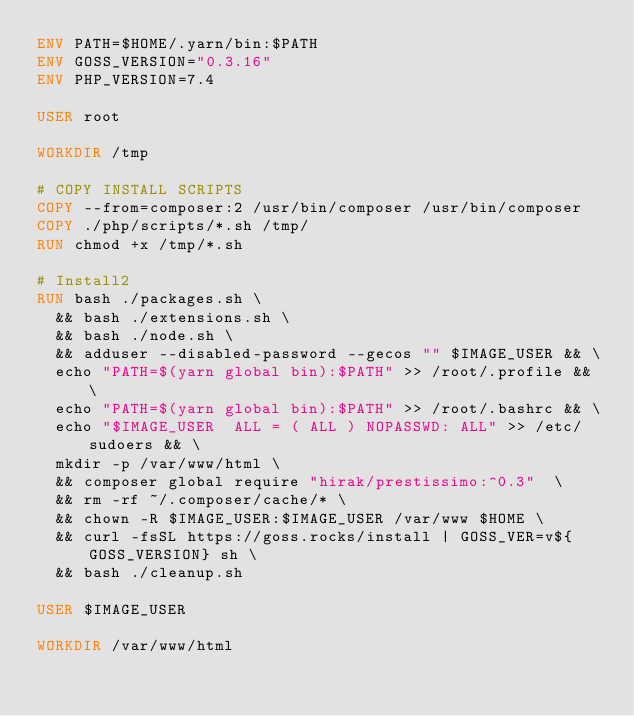Convert code to text. <code><loc_0><loc_0><loc_500><loc_500><_Dockerfile_>ENV PATH=$HOME/.yarn/bin:$PATH
ENV GOSS_VERSION="0.3.16"
ENV PHP_VERSION=7.4

USER root

WORKDIR /tmp

# COPY INSTALL SCRIPTS
COPY --from=composer:2 /usr/bin/composer /usr/bin/composer
COPY ./php/scripts/*.sh /tmp/
RUN chmod +x /tmp/*.sh

# Install2
RUN bash ./packages.sh \
  && bash ./extensions.sh \
  && bash ./node.sh \
  && adduser --disabled-password --gecos "" $IMAGE_USER && \
  echo "PATH=$(yarn global bin):$PATH" >> /root/.profile && \
  echo "PATH=$(yarn global bin):$PATH" >> /root/.bashrc && \
  echo "$IMAGE_USER  ALL = ( ALL ) NOPASSWD: ALL" >> /etc/sudoers && \
  mkdir -p /var/www/html \
  && composer global require "hirak/prestissimo:^0.3"  \
  && rm -rf ~/.composer/cache/* \
  && chown -R $IMAGE_USER:$IMAGE_USER /var/www $HOME \
  && curl -fsSL https://goss.rocks/install | GOSS_VER=v${GOSS_VERSION} sh \
  && bash ./cleanup.sh

USER $IMAGE_USER

WORKDIR /var/www/html
</code> 